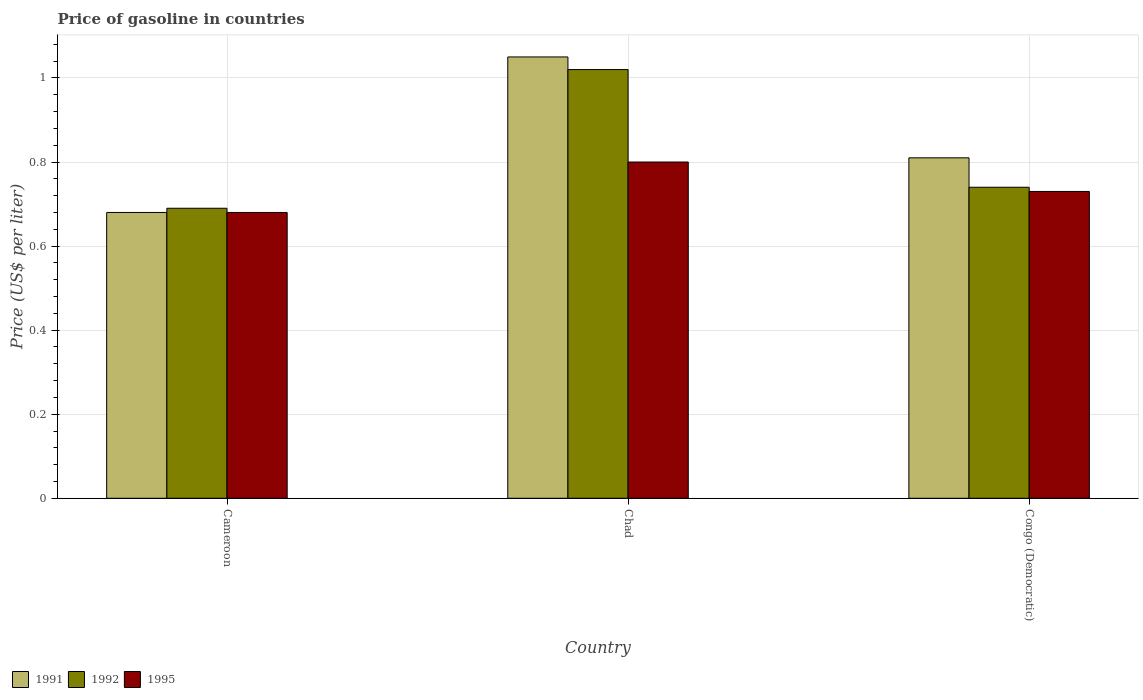How many different coloured bars are there?
Provide a succinct answer. 3. How many groups of bars are there?
Make the answer very short. 3. Are the number of bars per tick equal to the number of legend labels?
Give a very brief answer. Yes. Are the number of bars on each tick of the X-axis equal?
Offer a terse response. Yes. How many bars are there on the 2nd tick from the right?
Make the answer very short. 3. What is the label of the 3rd group of bars from the left?
Ensure brevity in your answer.  Congo (Democratic). What is the price of gasoline in 1995 in Cameroon?
Offer a terse response. 0.68. Across all countries, what is the maximum price of gasoline in 1995?
Your answer should be very brief. 0.8. Across all countries, what is the minimum price of gasoline in 1992?
Provide a succinct answer. 0.69. In which country was the price of gasoline in 1991 maximum?
Your answer should be very brief. Chad. In which country was the price of gasoline in 1992 minimum?
Make the answer very short. Cameroon. What is the total price of gasoline in 1995 in the graph?
Your response must be concise. 2.21. What is the difference between the price of gasoline in 1991 in Chad and that in Congo (Democratic)?
Offer a terse response. 0.24. What is the difference between the price of gasoline in 1992 in Chad and the price of gasoline in 1991 in Cameroon?
Give a very brief answer. 0.34. What is the average price of gasoline in 1991 per country?
Your answer should be compact. 0.85. What is the difference between the price of gasoline of/in 1991 and price of gasoline of/in 1995 in Chad?
Provide a short and direct response. 0.25. In how many countries, is the price of gasoline in 1991 greater than 0.6000000000000001 US$?
Provide a succinct answer. 3. What is the ratio of the price of gasoline in 1995 in Cameroon to that in Congo (Democratic)?
Offer a very short reply. 0.93. Is the price of gasoline in 1992 in Chad less than that in Congo (Democratic)?
Make the answer very short. No. Is the difference between the price of gasoline in 1991 in Cameroon and Chad greater than the difference between the price of gasoline in 1995 in Cameroon and Chad?
Give a very brief answer. No. What is the difference between the highest and the second highest price of gasoline in 1995?
Your answer should be very brief. 0.07. What is the difference between the highest and the lowest price of gasoline in 1992?
Your response must be concise. 0.33. What does the 1st bar from the left in Chad represents?
Your response must be concise. 1991. What does the 2nd bar from the right in Cameroon represents?
Your answer should be very brief. 1992. Is it the case that in every country, the sum of the price of gasoline in 1992 and price of gasoline in 1991 is greater than the price of gasoline in 1995?
Ensure brevity in your answer.  Yes. How many bars are there?
Your answer should be compact. 9. What is the difference between two consecutive major ticks on the Y-axis?
Offer a terse response. 0.2. Are the values on the major ticks of Y-axis written in scientific E-notation?
Your answer should be very brief. No. Where does the legend appear in the graph?
Make the answer very short. Bottom left. How many legend labels are there?
Offer a very short reply. 3. How are the legend labels stacked?
Provide a succinct answer. Horizontal. What is the title of the graph?
Offer a terse response. Price of gasoline in countries. Does "1970" appear as one of the legend labels in the graph?
Keep it short and to the point. No. What is the label or title of the Y-axis?
Your answer should be compact. Price (US$ per liter). What is the Price (US$ per liter) of 1991 in Cameroon?
Your answer should be compact. 0.68. What is the Price (US$ per liter) in 1992 in Cameroon?
Keep it short and to the point. 0.69. What is the Price (US$ per liter) in 1995 in Cameroon?
Provide a short and direct response. 0.68. What is the Price (US$ per liter) in 1995 in Chad?
Your answer should be compact. 0.8. What is the Price (US$ per liter) of 1991 in Congo (Democratic)?
Provide a succinct answer. 0.81. What is the Price (US$ per liter) of 1992 in Congo (Democratic)?
Provide a short and direct response. 0.74. What is the Price (US$ per liter) of 1995 in Congo (Democratic)?
Ensure brevity in your answer.  0.73. Across all countries, what is the maximum Price (US$ per liter) in 1992?
Provide a short and direct response. 1.02. Across all countries, what is the maximum Price (US$ per liter) of 1995?
Your answer should be very brief. 0.8. Across all countries, what is the minimum Price (US$ per liter) in 1991?
Give a very brief answer. 0.68. Across all countries, what is the minimum Price (US$ per liter) in 1992?
Give a very brief answer. 0.69. Across all countries, what is the minimum Price (US$ per liter) in 1995?
Your answer should be compact. 0.68. What is the total Price (US$ per liter) in 1991 in the graph?
Make the answer very short. 2.54. What is the total Price (US$ per liter) of 1992 in the graph?
Provide a short and direct response. 2.45. What is the total Price (US$ per liter) in 1995 in the graph?
Your answer should be very brief. 2.21. What is the difference between the Price (US$ per liter) of 1991 in Cameroon and that in Chad?
Your answer should be compact. -0.37. What is the difference between the Price (US$ per liter) of 1992 in Cameroon and that in Chad?
Your response must be concise. -0.33. What is the difference between the Price (US$ per liter) of 1995 in Cameroon and that in Chad?
Provide a short and direct response. -0.12. What is the difference between the Price (US$ per liter) of 1991 in Cameroon and that in Congo (Democratic)?
Provide a succinct answer. -0.13. What is the difference between the Price (US$ per liter) of 1992 in Cameroon and that in Congo (Democratic)?
Provide a short and direct response. -0.05. What is the difference between the Price (US$ per liter) in 1991 in Chad and that in Congo (Democratic)?
Provide a short and direct response. 0.24. What is the difference between the Price (US$ per liter) in 1992 in Chad and that in Congo (Democratic)?
Ensure brevity in your answer.  0.28. What is the difference between the Price (US$ per liter) in 1995 in Chad and that in Congo (Democratic)?
Offer a very short reply. 0.07. What is the difference between the Price (US$ per liter) in 1991 in Cameroon and the Price (US$ per liter) in 1992 in Chad?
Your answer should be compact. -0.34. What is the difference between the Price (US$ per liter) of 1991 in Cameroon and the Price (US$ per liter) of 1995 in Chad?
Your response must be concise. -0.12. What is the difference between the Price (US$ per liter) of 1992 in Cameroon and the Price (US$ per liter) of 1995 in Chad?
Offer a very short reply. -0.11. What is the difference between the Price (US$ per liter) in 1991 in Cameroon and the Price (US$ per liter) in 1992 in Congo (Democratic)?
Offer a terse response. -0.06. What is the difference between the Price (US$ per liter) in 1991 in Cameroon and the Price (US$ per liter) in 1995 in Congo (Democratic)?
Your answer should be compact. -0.05. What is the difference between the Price (US$ per liter) in 1992 in Cameroon and the Price (US$ per liter) in 1995 in Congo (Democratic)?
Give a very brief answer. -0.04. What is the difference between the Price (US$ per liter) of 1991 in Chad and the Price (US$ per liter) of 1992 in Congo (Democratic)?
Offer a terse response. 0.31. What is the difference between the Price (US$ per liter) in 1991 in Chad and the Price (US$ per liter) in 1995 in Congo (Democratic)?
Provide a succinct answer. 0.32. What is the difference between the Price (US$ per liter) in 1992 in Chad and the Price (US$ per liter) in 1995 in Congo (Democratic)?
Your answer should be very brief. 0.29. What is the average Price (US$ per liter) in 1991 per country?
Offer a very short reply. 0.85. What is the average Price (US$ per liter) of 1992 per country?
Your answer should be very brief. 0.82. What is the average Price (US$ per liter) of 1995 per country?
Offer a very short reply. 0.74. What is the difference between the Price (US$ per liter) of 1991 and Price (US$ per liter) of 1992 in Cameroon?
Your answer should be compact. -0.01. What is the difference between the Price (US$ per liter) of 1991 and Price (US$ per liter) of 1995 in Cameroon?
Offer a terse response. 0. What is the difference between the Price (US$ per liter) of 1992 and Price (US$ per liter) of 1995 in Cameroon?
Give a very brief answer. 0.01. What is the difference between the Price (US$ per liter) of 1991 and Price (US$ per liter) of 1992 in Chad?
Your response must be concise. 0.03. What is the difference between the Price (US$ per liter) in 1991 and Price (US$ per liter) in 1995 in Chad?
Your answer should be compact. 0.25. What is the difference between the Price (US$ per liter) of 1992 and Price (US$ per liter) of 1995 in Chad?
Make the answer very short. 0.22. What is the difference between the Price (US$ per liter) in 1991 and Price (US$ per liter) in 1992 in Congo (Democratic)?
Keep it short and to the point. 0.07. What is the difference between the Price (US$ per liter) of 1992 and Price (US$ per liter) of 1995 in Congo (Democratic)?
Give a very brief answer. 0.01. What is the ratio of the Price (US$ per liter) of 1991 in Cameroon to that in Chad?
Provide a succinct answer. 0.65. What is the ratio of the Price (US$ per liter) of 1992 in Cameroon to that in Chad?
Provide a short and direct response. 0.68. What is the ratio of the Price (US$ per liter) of 1991 in Cameroon to that in Congo (Democratic)?
Ensure brevity in your answer.  0.84. What is the ratio of the Price (US$ per liter) of 1992 in Cameroon to that in Congo (Democratic)?
Your answer should be very brief. 0.93. What is the ratio of the Price (US$ per liter) in 1995 in Cameroon to that in Congo (Democratic)?
Offer a very short reply. 0.93. What is the ratio of the Price (US$ per liter) of 1991 in Chad to that in Congo (Democratic)?
Your response must be concise. 1.3. What is the ratio of the Price (US$ per liter) in 1992 in Chad to that in Congo (Democratic)?
Make the answer very short. 1.38. What is the ratio of the Price (US$ per liter) in 1995 in Chad to that in Congo (Democratic)?
Keep it short and to the point. 1.1. What is the difference between the highest and the second highest Price (US$ per liter) in 1991?
Keep it short and to the point. 0.24. What is the difference between the highest and the second highest Price (US$ per liter) in 1992?
Your answer should be very brief. 0.28. What is the difference between the highest and the second highest Price (US$ per liter) in 1995?
Offer a very short reply. 0.07. What is the difference between the highest and the lowest Price (US$ per liter) of 1991?
Give a very brief answer. 0.37. What is the difference between the highest and the lowest Price (US$ per liter) of 1992?
Your answer should be very brief. 0.33. What is the difference between the highest and the lowest Price (US$ per liter) of 1995?
Keep it short and to the point. 0.12. 